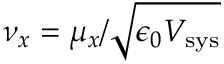Convert formula to latex. <formula><loc_0><loc_0><loc_500><loc_500>\nu _ { x } = { \mu _ { x } / \sqrt { \epsilon _ { 0 } V _ { s y s } } }</formula> 